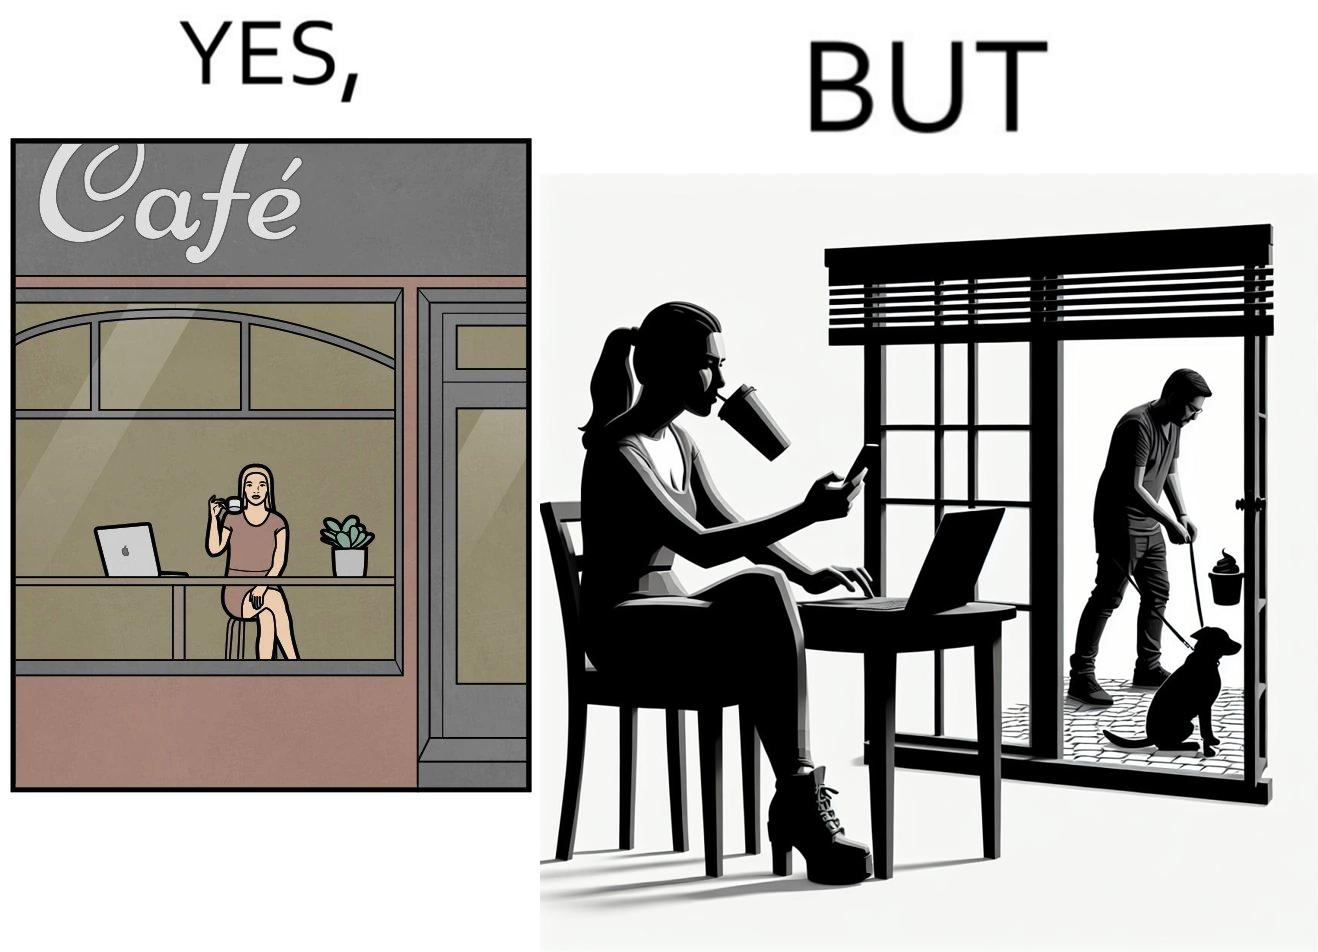What is the satirical meaning behind this image? The image is ironic, because in the first image the woman is seen as enjoying the view but in the second image the same woman is seen as looking at a pooping dog 